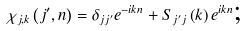<formula> <loc_0><loc_0><loc_500><loc_500>\chi _ { j , k } \left ( j ^ { \prime } , n \right ) = \delta _ { j j ^ { \prime } } e ^ { - i k n } + S _ { j ^ { \prime } j } \left ( k \right ) e ^ { i k n } \text {;}</formula> 